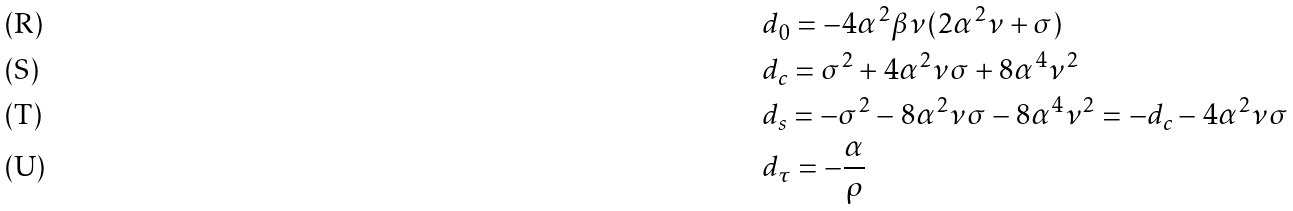<formula> <loc_0><loc_0><loc_500><loc_500>& d _ { 0 } = - 4 \alpha ^ { 2 } \beta \nu ( 2 \alpha ^ { 2 } \nu + \sigma ) \\ & d _ { c } = \sigma ^ { 2 } + 4 \alpha ^ { 2 } \nu \sigma + 8 \alpha ^ { 4 } \nu ^ { 2 } \\ & d _ { s } = - \sigma ^ { 2 } - 8 \alpha ^ { 2 } \nu \sigma - 8 \alpha ^ { 4 } \nu ^ { 2 } = - d _ { c } - 4 \alpha ^ { 2 } \nu \sigma \\ & d _ { \tau } = - \frac { \alpha } { \rho }</formula> 